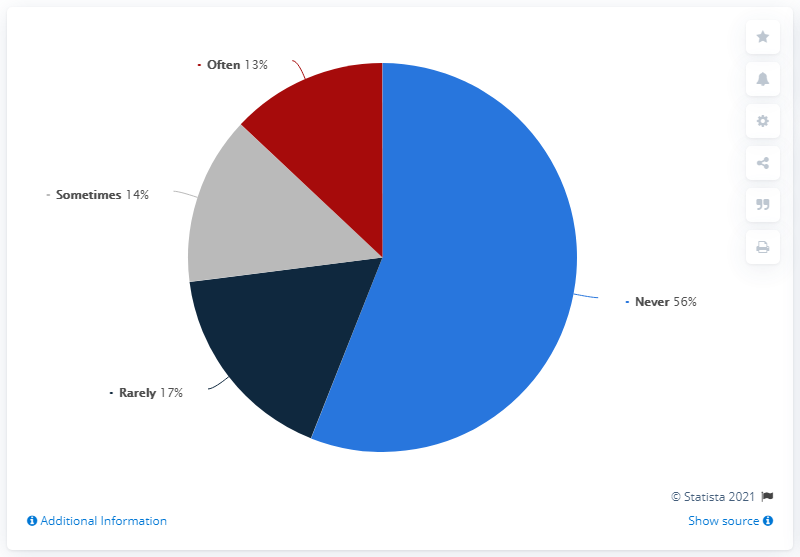Highlight a few significant elements in this photo. The response with the lowest answer rate is 'often.' The average of rarely, sometimes, and often is 14.67. 